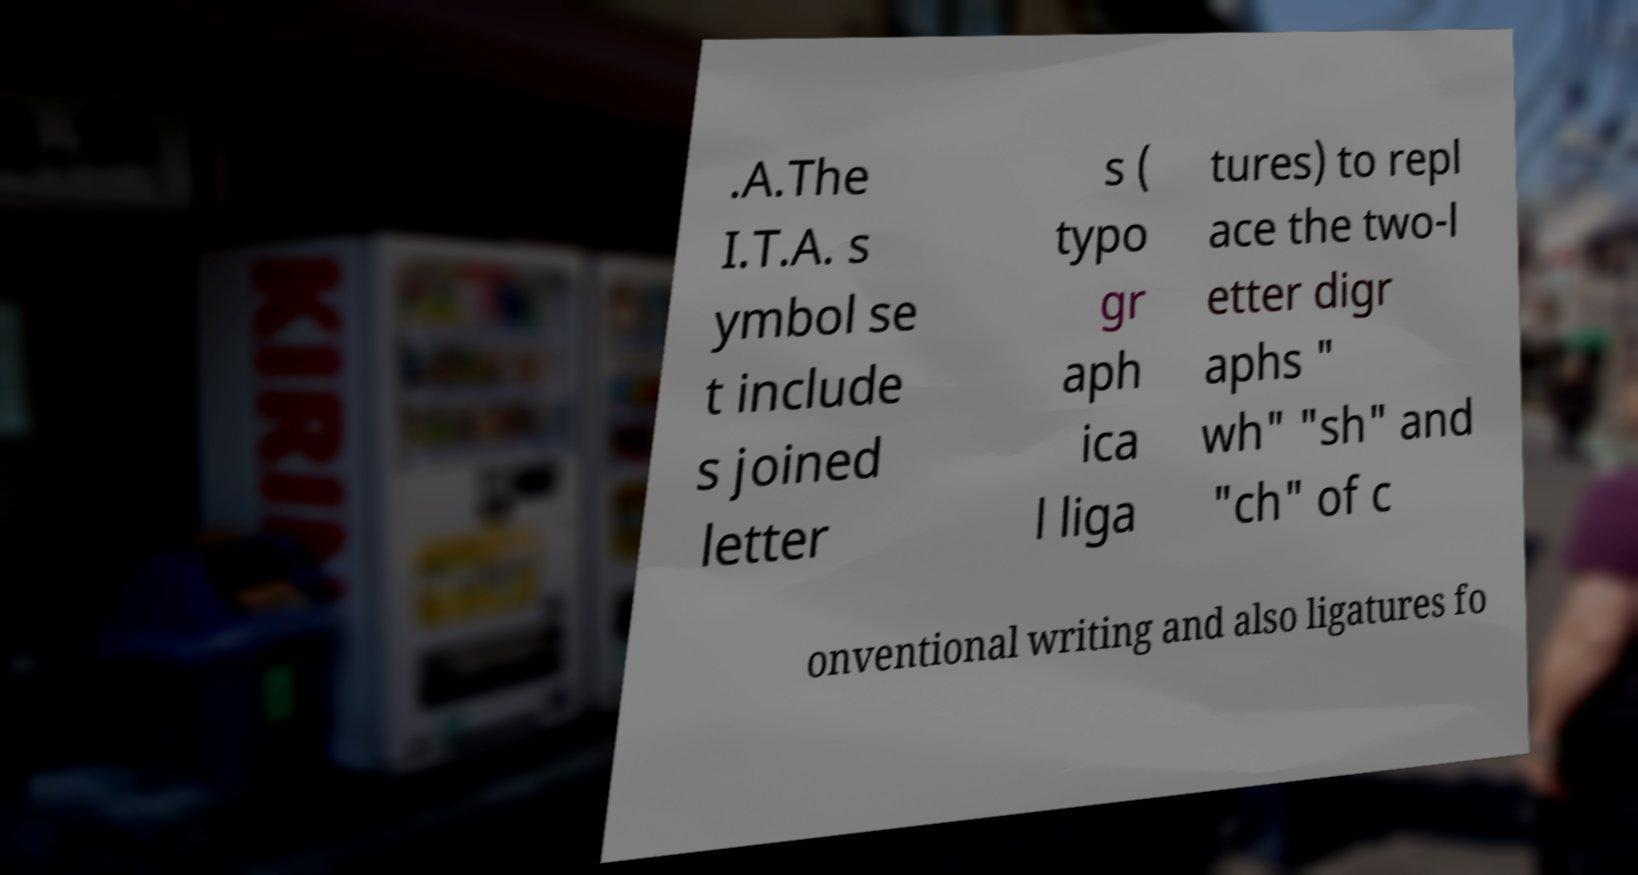Can you accurately transcribe the text from the provided image for me? .A.The I.T.A. s ymbol se t include s joined letter s ( typo gr aph ica l liga tures) to repl ace the two-l etter digr aphs " wh" "sh" and "ch" of c onventional writing and also ligatures fo 